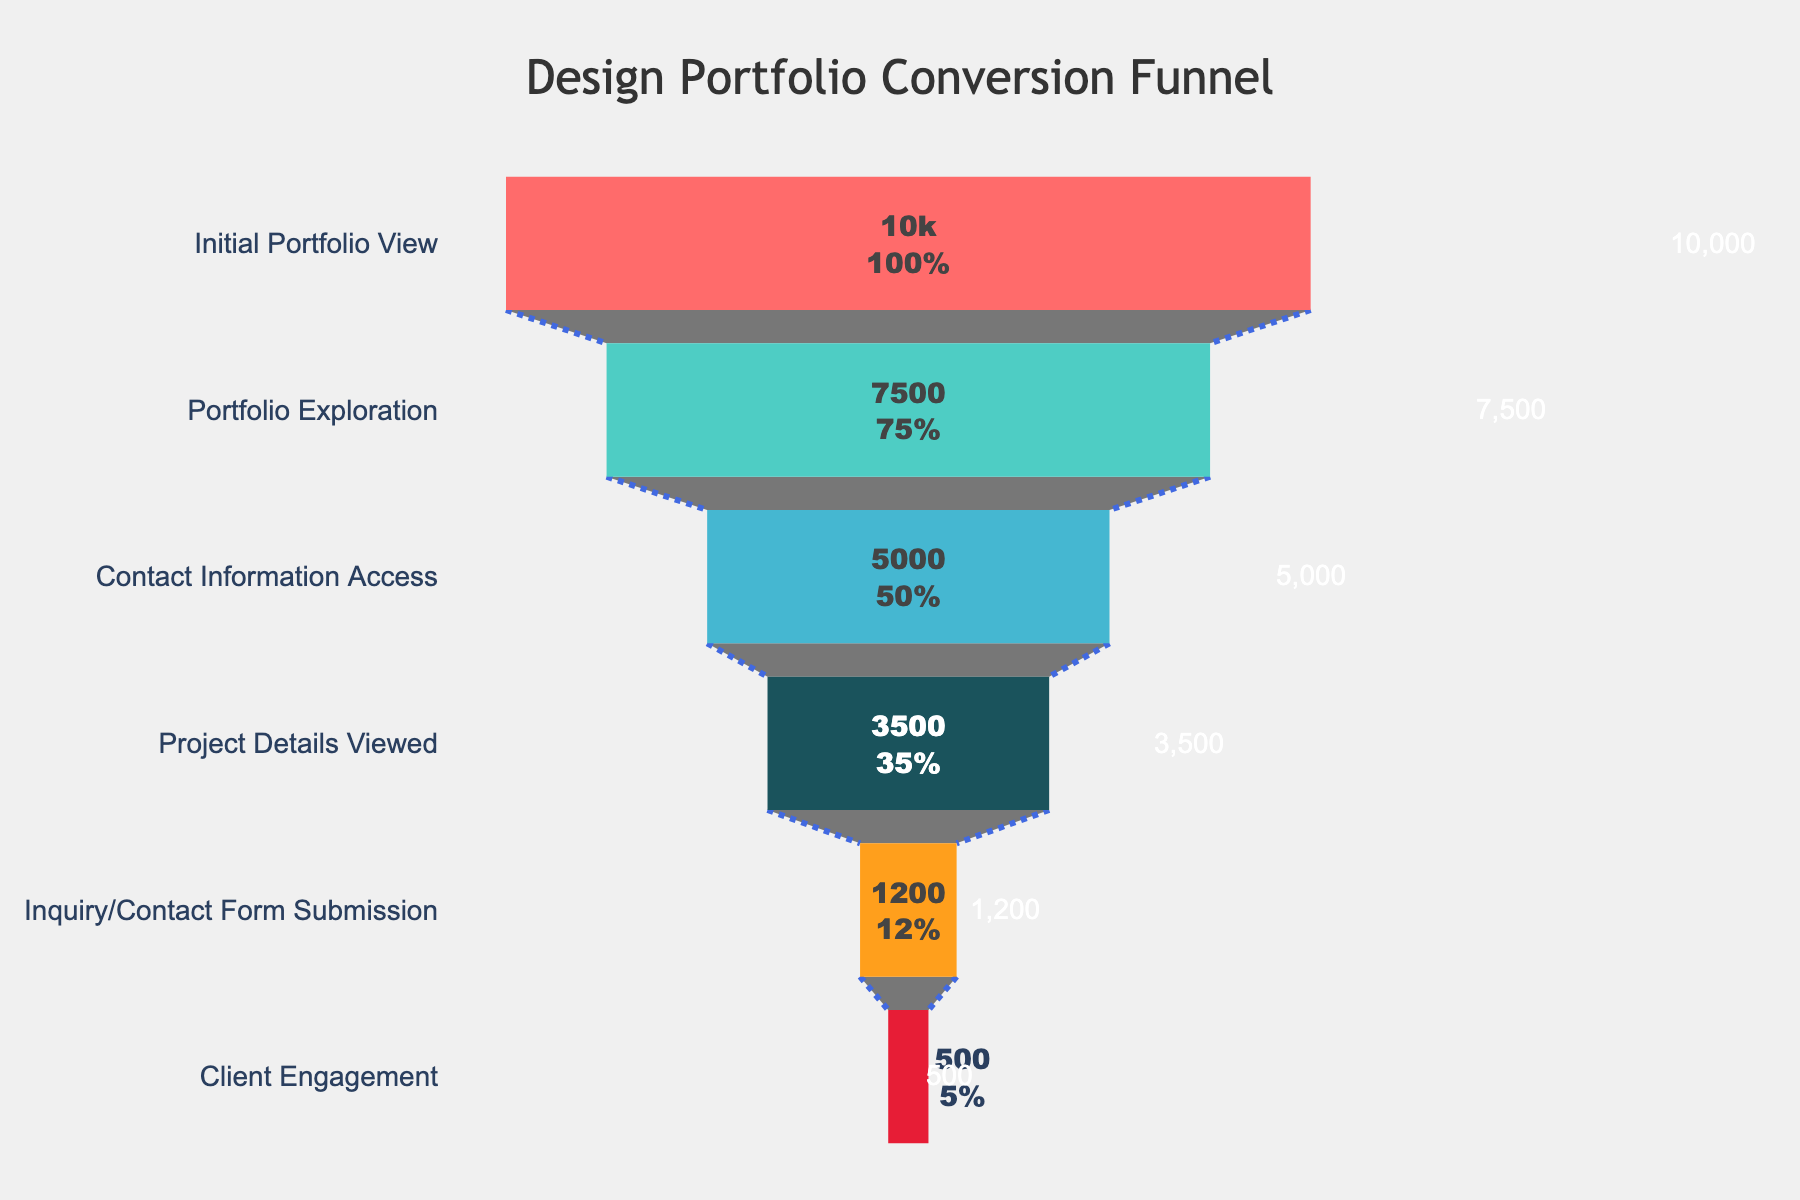Which stage has the highest number of visitors? The stage with the highest number of visitors can be directly read from the top of the funnel, which is the "Initial Portfolio View" with 10,000 visitors.
Answer: Initial Portfolio View What percentage of visitors move from Portfolio Exploration to Contact Information Access? The number of visitors at the Portfolio Exploration stage is 7,500, and the number of visitors at the Contact Information Access stage is 5,000. The percentage is calculated as (5,000 / 7,500) * 100%.
Answer: 66.67% How many visitors are lost between the Project Details Viewed stage and the Inquiry/Contact Form Submission stage? The number of visitors at the Project Details Viewed stage is 3,500, while the number of visitors at the Inquiry/Contact Form Submission stage is 1,200. Subtracting these gives the number of visitors lost: 3,500 - 1,200.
Answer: 2,300 Is the decrease in visitors greater between Contact Information Access to Project Details Viewed, or Inquiry/Contact Form Submission to Client Engagement? First, calculate the decreases: from Contact Information Access to Project Details Viewed is 5,000 - 3,500 = 1,500, and from Inquiry/Contact Form Submission to Client Engagement is 1,200 - 500 = 700. Comparing these two decreases, 1,500 is greater than 700.
Answer: Contact Information Access to Project Details Viewed What percentage of the initial visitors reaches Client Engagement? The number of visitors at the initial stage is 10,000, and the number of visitors who reach the Client Engagement stage is 500. The percentage is calculated as (500 / 10,000) * 100%.
Answer: 5% Which stage shows the most significant drop in visitors in terms of percentage? To find the most significant percentage drop, calculate the percentage decrease between each consecutive stage and compare them. The most significant drop can be identified directly without detailed calculation by visually inspecting the figure as the stage with the smallest number following a stage with a significantly higher number, which is from Project Details Viewed to Inquiry/Contact Form Submission.
Answer: Project Details Viewed to Inquiry/Contact Form Submission Can you list the stages in order from the highest to the lowest number of visitors? The stages can be ordered by their number of visitors as follows: Initial Portfolio View (10,000), Portfolio Exploration (7,500), Contact Information Access (5,000), Project Details Viewed (3,500), Inquiry/Contact Form Submission (1,200), Client Engagement (500).
Answer: Initial Portfolio View, Portfolio Exploration, Contact Information Access, Project Details Viewed, Inquiry/Contact Form Submission, Client Engagement How many visitors in total are lost from the initial view stage to the final engagement? The number of visitors lost is the difference between the initial visitors and the final stage visitors: 10,000 - 500.
Answer: 9,500 